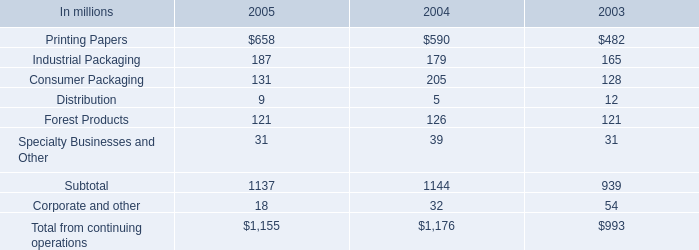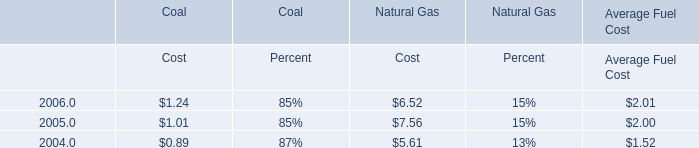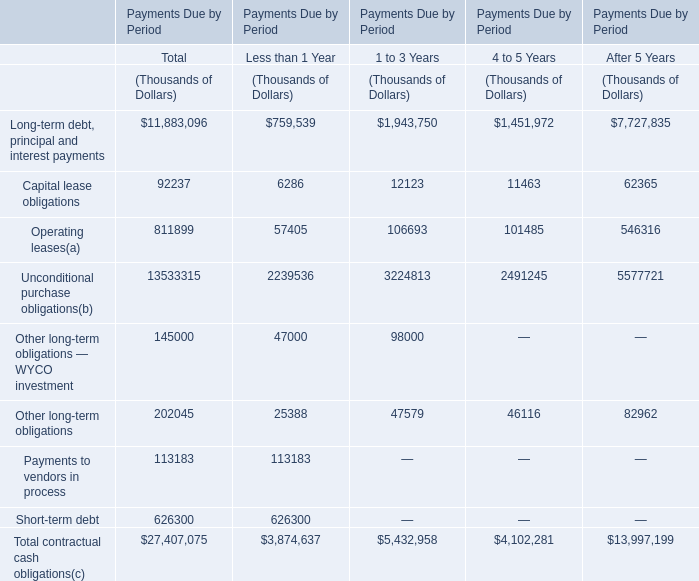Which section does Long-term debt, principal and interest payments reach the largest value? 
Answer: Total. What's the sum of all Long-term debt, principal and interest payments that are positive in Payments Due by Period (in thousand) 
Computations: (((759539 + 1943750) + 1451972) + 7727835)
Answer: 11883096.0. 